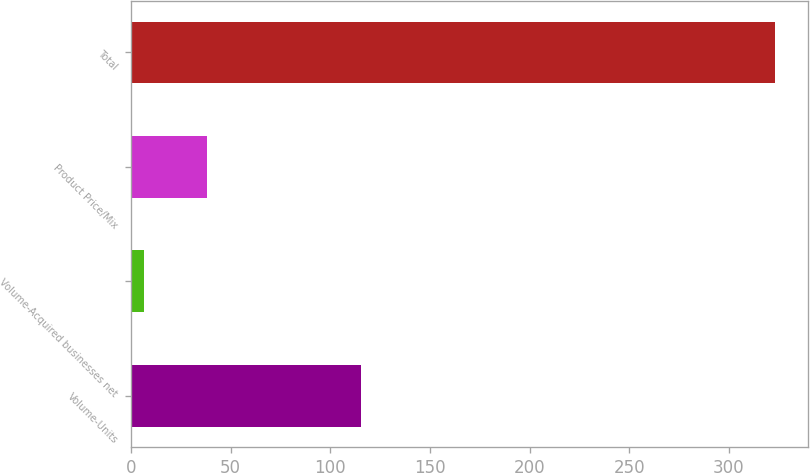<chart> <loc_0><loc_0><loc_500><loc_500><bar_chart><fcel>Volume-Units<fcel>Volume-Acquired businesses net<fcel>Product Price/Mix<fcel>Total<nl><fcel>115.5<fcel>6.3<fcel>38<fcel>323.3<nl></chart> 